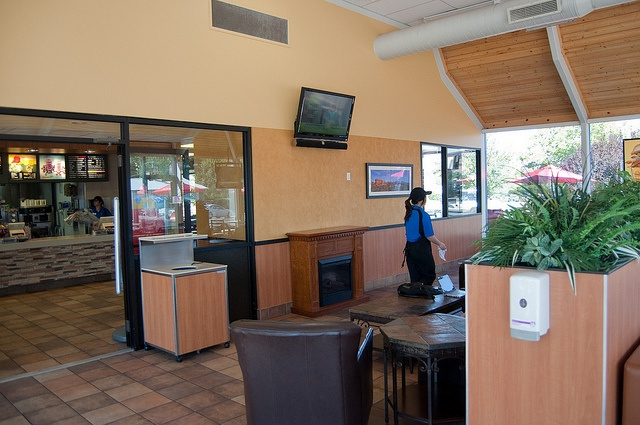Describe the objects in this image and their specific colors. I can see chair in tan, black, and gray tones, potted plant in tan, darkgreen, teal, and black tones, tv in tan, gray, black, purple, and darkgreen tones, people in tan, black, blue, and gray tones, and dining table in tan, black, maroon, and gray tones in this image. 